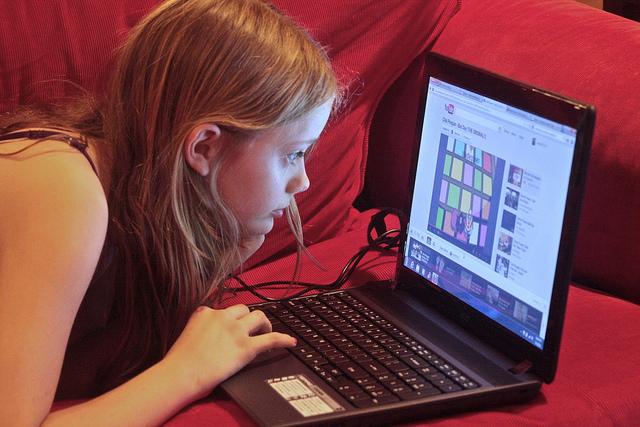What operating system is the girl using?
Write a very short answer. Windows. What is the girl doing on the computer?
Give a very brief answer. Browsing. What color is the chair?
Keep it brief. Red. How many laptops are on the table?
Answer briefly. 1. 